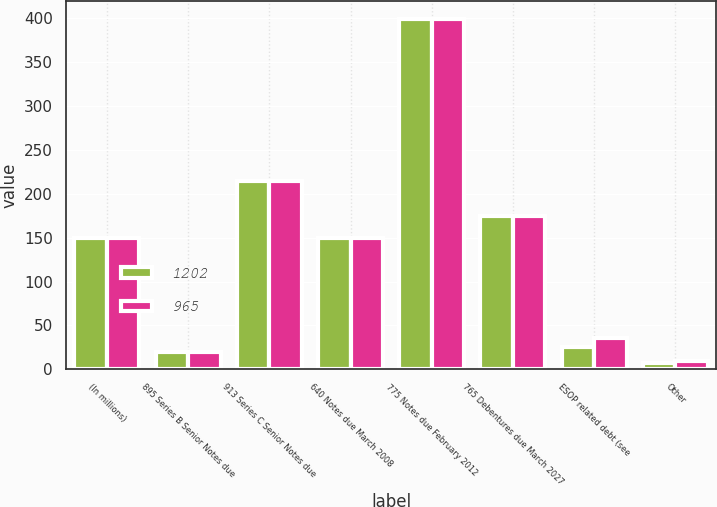<chart> <loc_0><loc_0><loc_500><loc_500><stacked_bar_chart><ecel><fcel>(In millions)<fcel>895 Series B Senior Notes due<fcel>913 Series C Senior Notes due<fcel>640 Notes due March 2008<fcel>775 Notes due February 2012<fcel>765 Debentures due March 2027<fcel>ESOP related debt (see<fcel>Other<nl><fcel>1202<fcel>150<fcel>20<fcel>215<fcel>150<fcel>399<fcel>175<fcel>25<fcel>7<nl><fcel>965<fcel>150<fcel>20<fcel>215<fcel>150<fcel>399<fcel>175<fcel>36<fcel>10<nl></chart> 